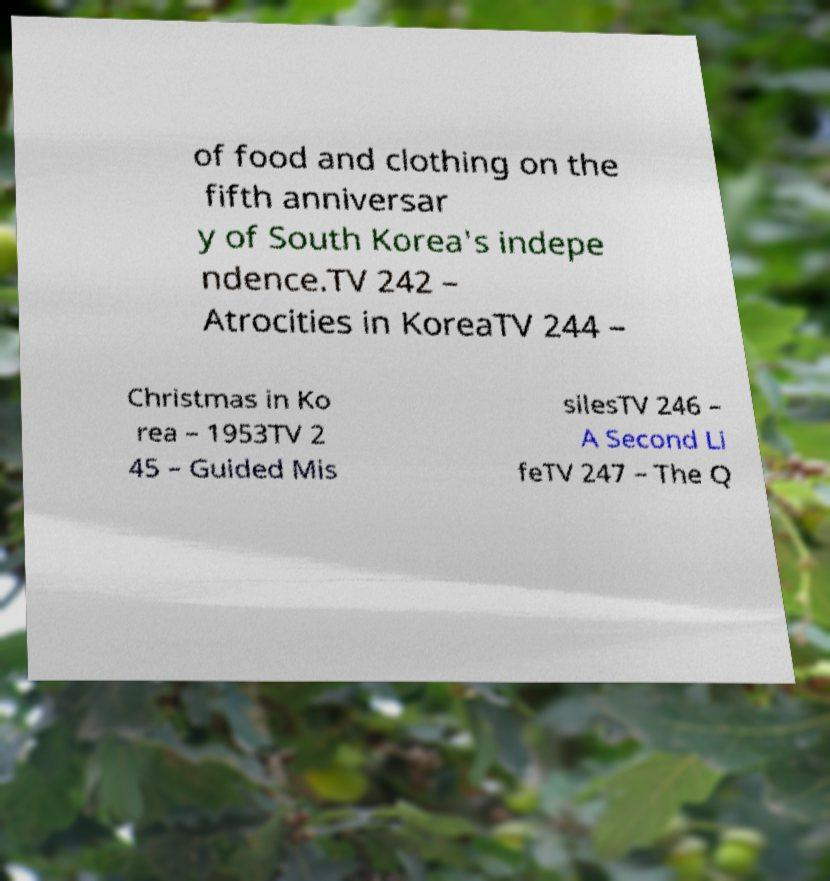There's text embedded in this image that I need extracted. Can you transcribe it verbatim? of food and clothing on the fifth anniversar y of South Korea's indepe ndence.TV 242 – Atrocities in KoreaTV 244 – Christmas in Ko rea – 1953TV 2 45 – Guided Mis silesTV 246 – A Second Li feTV 247 – The Q 